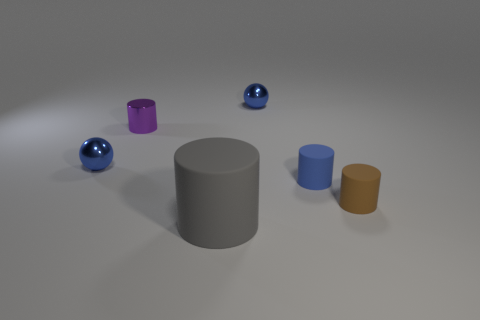What color is the other small metal thing that is the same shape as the tiny brown thing?
Your answer should be compact. Purple. What color is the metal cylinder?
Your answer should be very brief. Purple. There is a rubber thing that is behind the small brown matte object; are there any purple metal cylinders that are right of it?
Provide a short and direct response. No. There is a rubber object that is behind the rubber thing that is right of the blue rubber thing; what shape is it?
Your answer should be compact. Cylinder. Are there fewer metallic things than purple things?
Provide a succinct answer. No. Is the material of the small purple thing the same as the tiny blue cylinder?
Provide a succinct answer. No. What is the color of the tiny cylinder that is to the left of the brown matte cylinder and to the right of the purple thing?
Keep it short and to the point. Blue. Is there a metallic sphere that has the same size as the brown cylinder?
Provide a short and direct response. Yes. How big is the rubber object behind the rubber cylinder that is on the right side of the blue matte object?
Offer a terse response. Small. Are there fewer brown objects behind the tiny blue matte cylinder than big spheres?
Your answer should be very brief. No. 